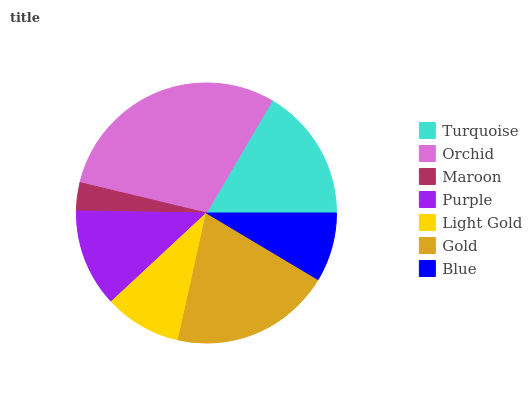Is Maroon the minimum?
Answer yes or no. Yes. Is Orchid the maximum?
Answer yes or no. Yes. Is Orchid the minimum?
Answer yes or no. No. Is Maroon the maximum?
Answer yes or no. No. Is Orchid greater than Maroon?
Answer yes or no. Yes. Is Maroon less than Orchid?
Answer yes or no. Yes. Is Maroon greater than Orchid?
Answer yes or no. No. Is Orchid less than Maroon?
Answer yes or no. No. Is Purple the high median?
Answer yes or no. Yes. Is Purple the low median?
Answer yes or no. Yes. Is Light Gold the high median?
Answer yes or no. No. Is Light Gold the low median?
Answer yes or no. No. 